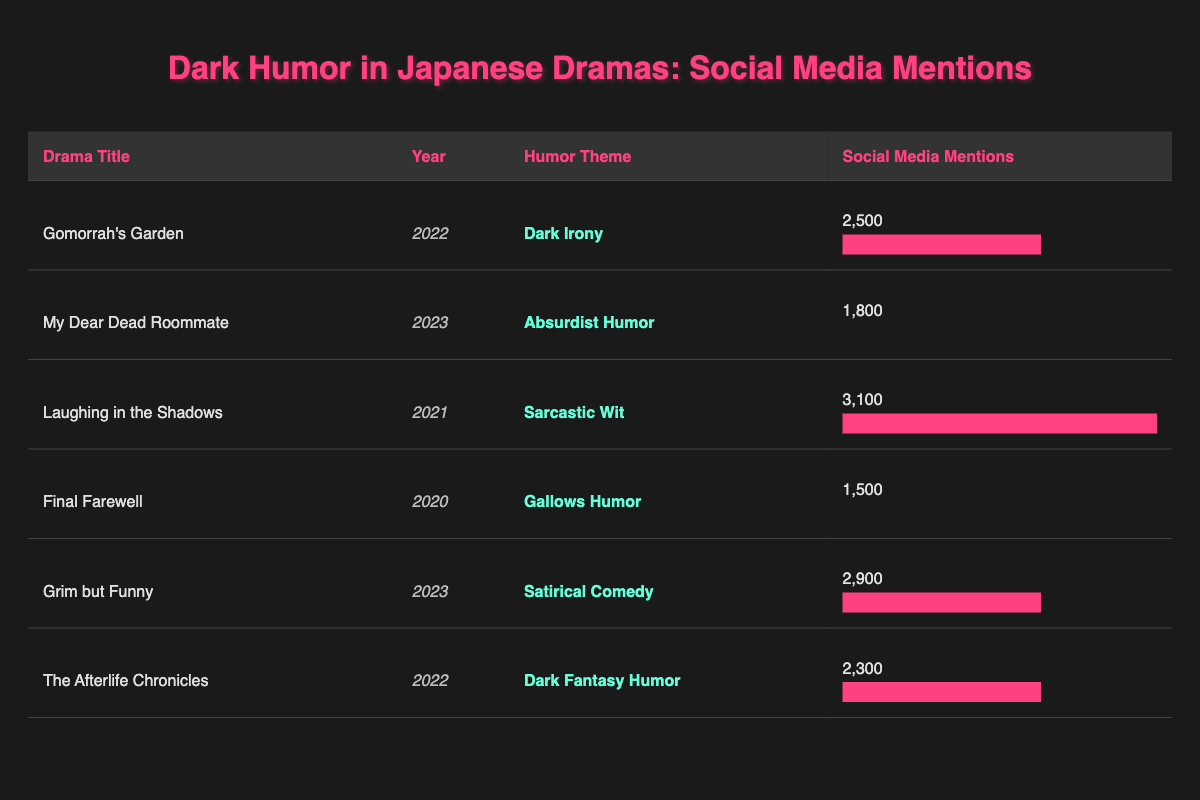What is the drama with the highest social media mentions? "Laughing in the Shadows" has the highest number of social media mentions at 3,100. You can find this by looking at the social media mentions column in the table and identifying the maximum value.
Answer: Laughing in the Shadows Which humor theme is associated with "My Dear Dead Roommate"? "My Dear Dead Roommate" has the humor theme of "absurdist humor," which is provided in the humor theme column adjacent to the drama title in the table.
Answer: Absurdist humor What is the average number of social media mentions for the dramas listed in the table? To find the average, sum up all mentions: 2500 + 1800 + 3100 + 1500 + 2900 + 2300 = 14500. There are 6 dramas, so divide: 14500 / 6 = 2416.67.
Answer: 2416.67 Did "Final Farewell" receive more than 2000 social media mentions? "Final Farewell" has 1,500 social media mentions, which is lower than 2,000. This can be checked directly by looking at the respective social media mentions in the table.
Answer: No Which drama has the closest social media mentions to the average? First, calculate the average (2416.67). The dramas closest to this value are "Gomorrah's Garden" (2500, 83.33 away) and "The Afterlife Chronicles" (2300, 116.67 away). "Gomorrah's Garden" is closer.
Answer: Gomorrah's Garden What is the total number of social media mentions for dramas with the "dark fantasy humor" theme? According to the table, "The Afterlife Chronicles" has 2300 mentions. Since it is the only drama with that theme, the total is simply 2300.
Answer: 2300 Which year saw the release of the drama with the second-highest social media mentions? The drama with the second-highest mentions is "Grim but Funny" (2,900 mentions), which was released in 2023. This can be established by ranking the social media mentions and noting the year associated with the drama.
Answer: 2023 Is "Gallows humor" a theme present in any other drama apart from "Final Farewell"? By checking the humor themes in the table, "Gallows humor" appears exclusively with "Final Farewell," so it is not found in any other listed drama.
Answer: No 